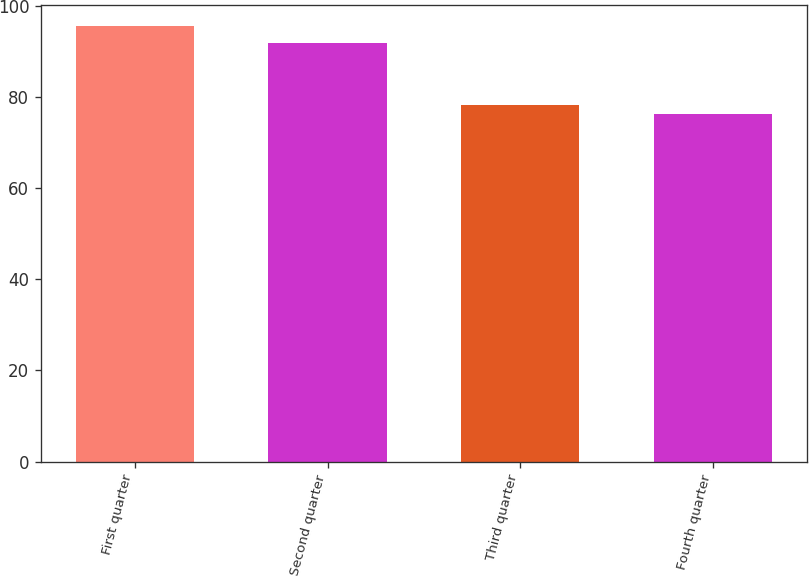Convert chart to OTSL. <chart><loc_0><loc_0><loc_500><loc_500><bar_chart><fcel>First quarter<fcel>Second quarter<fcel>Third quarter<fcel>Fourth quarter<nl><fcel>95.5<fcel>91.85<fcel>78.13<fcel>76.2<nl></chart> 